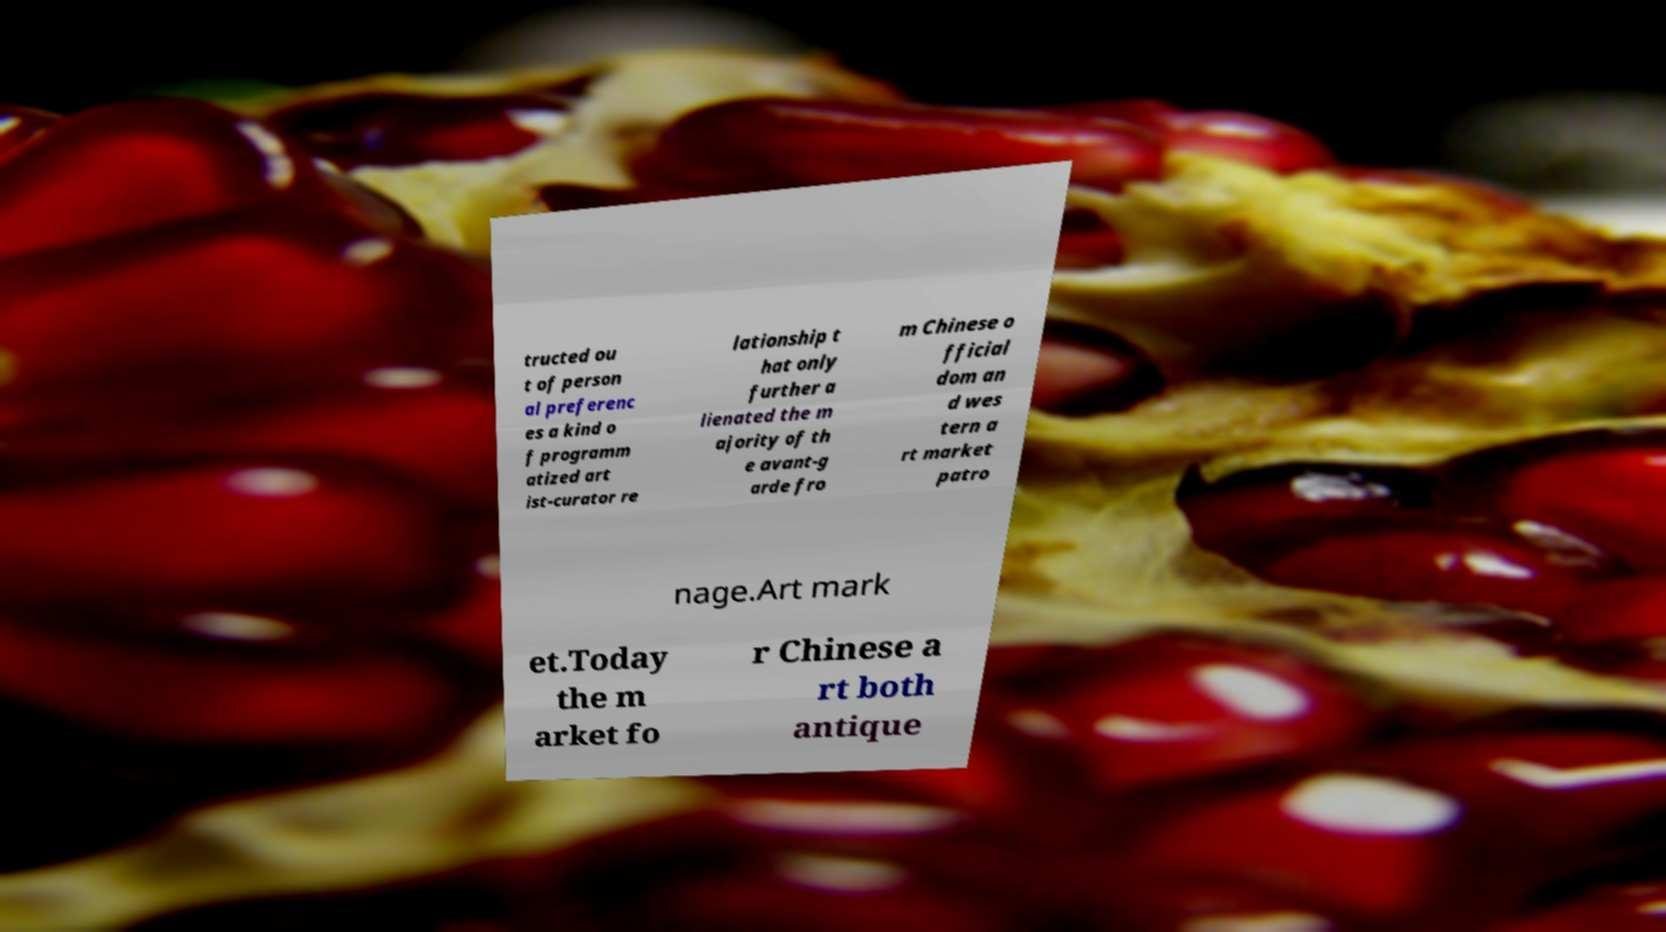I need the written content from this picture converted into text. Can you do that? tructed ou t of person al preferenc es a kind o f programm atized art ist-curator re lationship t hat only further a lienated the m ajority of th e avant-g arde fro m Chinese o fficial dom an d wes tern a rt market patro nage.Art mark et.Today the m arket fo r Chinese a rt both antique 